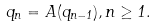Convert formula to latex. <formula><loc_0><loc_0><loc_500><loc_500>q _ { n } = A ( q _ { n - 1 } ) , n \geq 1 .</formula> 